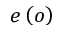<formula> <loc_0><loc_0><loc_500><loc_500>e \left ( o \right )</formula> 